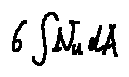<formula> <loc_0><loc_0><loc_500><loc_500>6 \int N _ { u } d A</formula> 